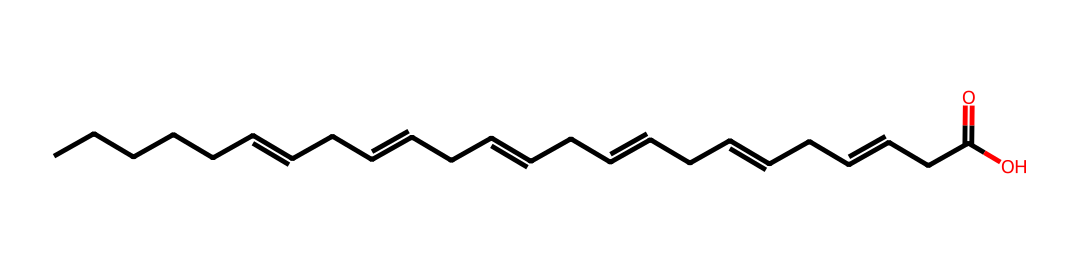How many carbon atoms are present in docosahexaenoic acid? The SMILES notation shows a long continuous chain with multiple carbon atoms, and counting each 'C' gives a total of 22 carbon atoms in DHA.
Answer: 22 What type of functional group is present in docosahexaenoic acid? The structure ends with a '-COOH' which indicates the presence of a carboxylic acid functional group, a characteristic feature of fatty acids.
Answer: carboxylic acid How many double bonds does docosahexaenoic acid contain? The SMILES representation includes '=' symbols, indicating double bonds between carbon atoms. Counting these gives a total of 6 double bonds in DHA.
Answer: 6 Is docosahexaenoic acid saturated or unsaturated? The presence of multiple double bonds in the structure indicates that this compound has unsaturated carbon chains, confirming it is an unsaturated fatty acid.
Answer: unsaturated Which aliphatic compound category does docosahexaenoic acid belong to? Given that it contains a straight-chain structure with a carboxylic acid group and multiple double bonds, DHA is categorized as an omega-3 fatty acid, a type of aliphatic compound.
Answer: omega-3 fatty acid What is the total number of hydrogen atoms in docosahexaenoic acid? The formula for calculating hydrogen in aliphatic compounds is generally based on the number of carbon atoms and double bonds. For DHA with 22 carbons and 6 double bonds, the hydrogen count is calculated to be 32.
Answer: 32 What is the primary source of docosahexaenoic acid in the diet? DHA is primarily derived from marine sources, particularly fish, as part of the omega-3 fatty acid group essential for human health.
Answer: fish 